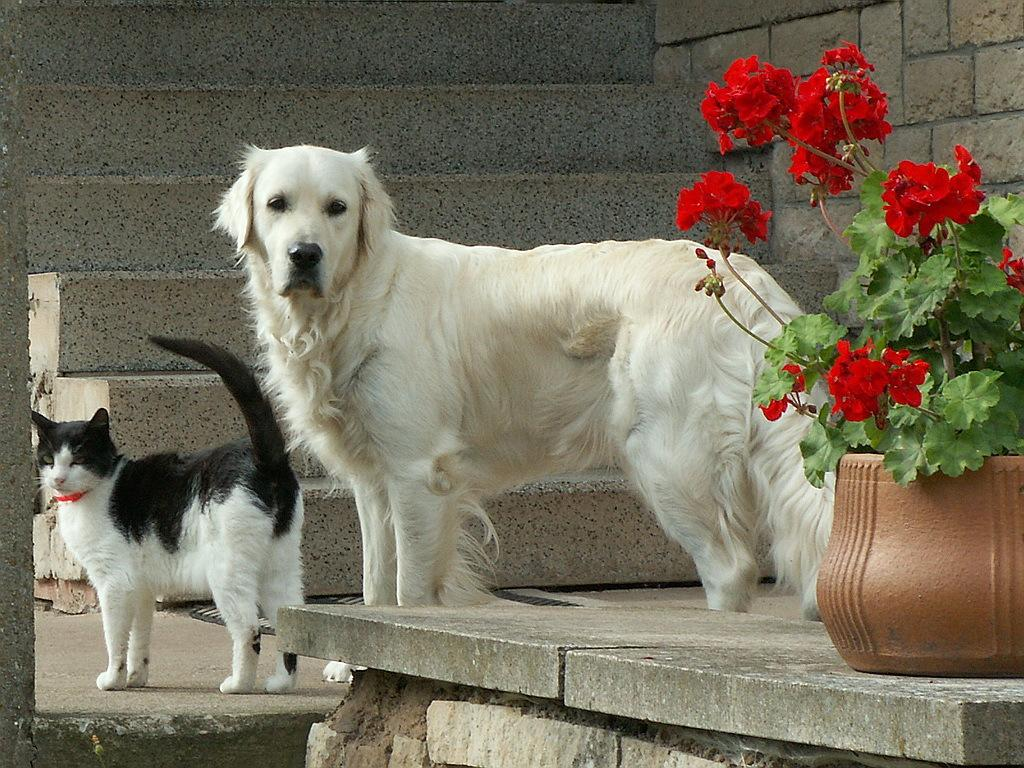What type of animal can be seen in the image? There is a white color dog in the image. Are there any other animals present in the image? Yes, there is a cat in the image. What can be seen on the right side of the image? There is a flower pot and steps on the right side of the image. What is the background of the image? There is a wall on the right side of the image. What type of feather can be seen falling from the sky in the image? There is no feather falling from the sky in the image. What type of glass object is visible on the ground in the image? There is no glass object visible on the ground in the image. 